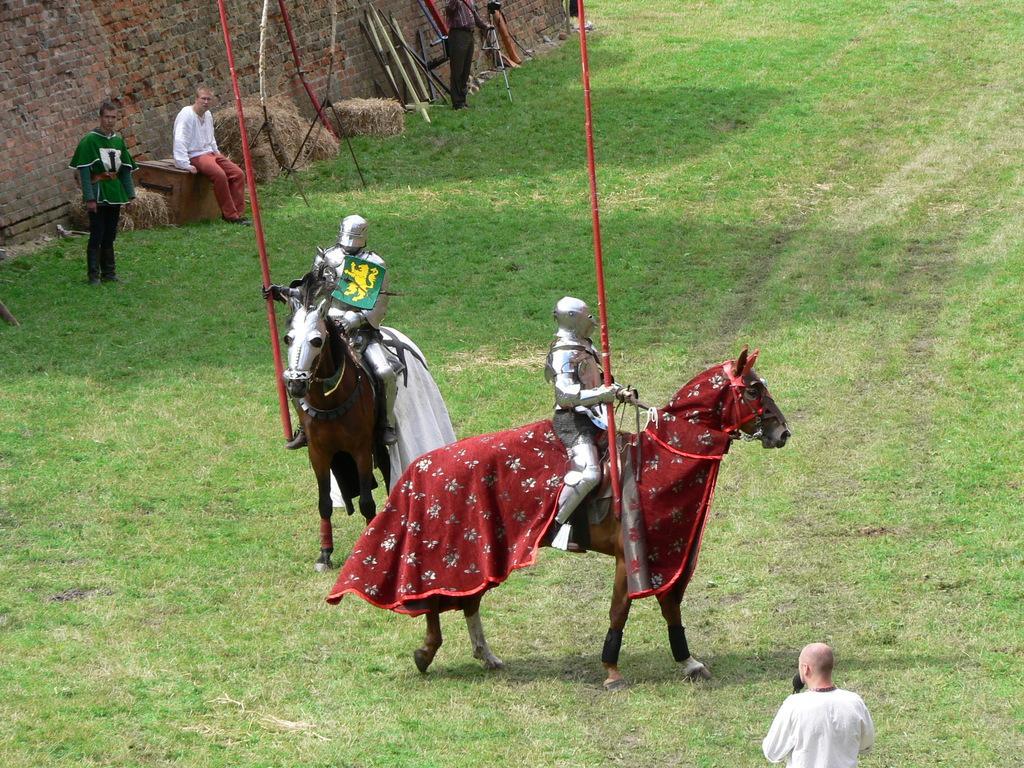Could you give a brief overview of what you see in this image? There are two people sitting on a horse separately. They are holding a wooden stick in their hand. There is a person who is sitting on a wooden block. There is a person standing on the left side and observing these people. 